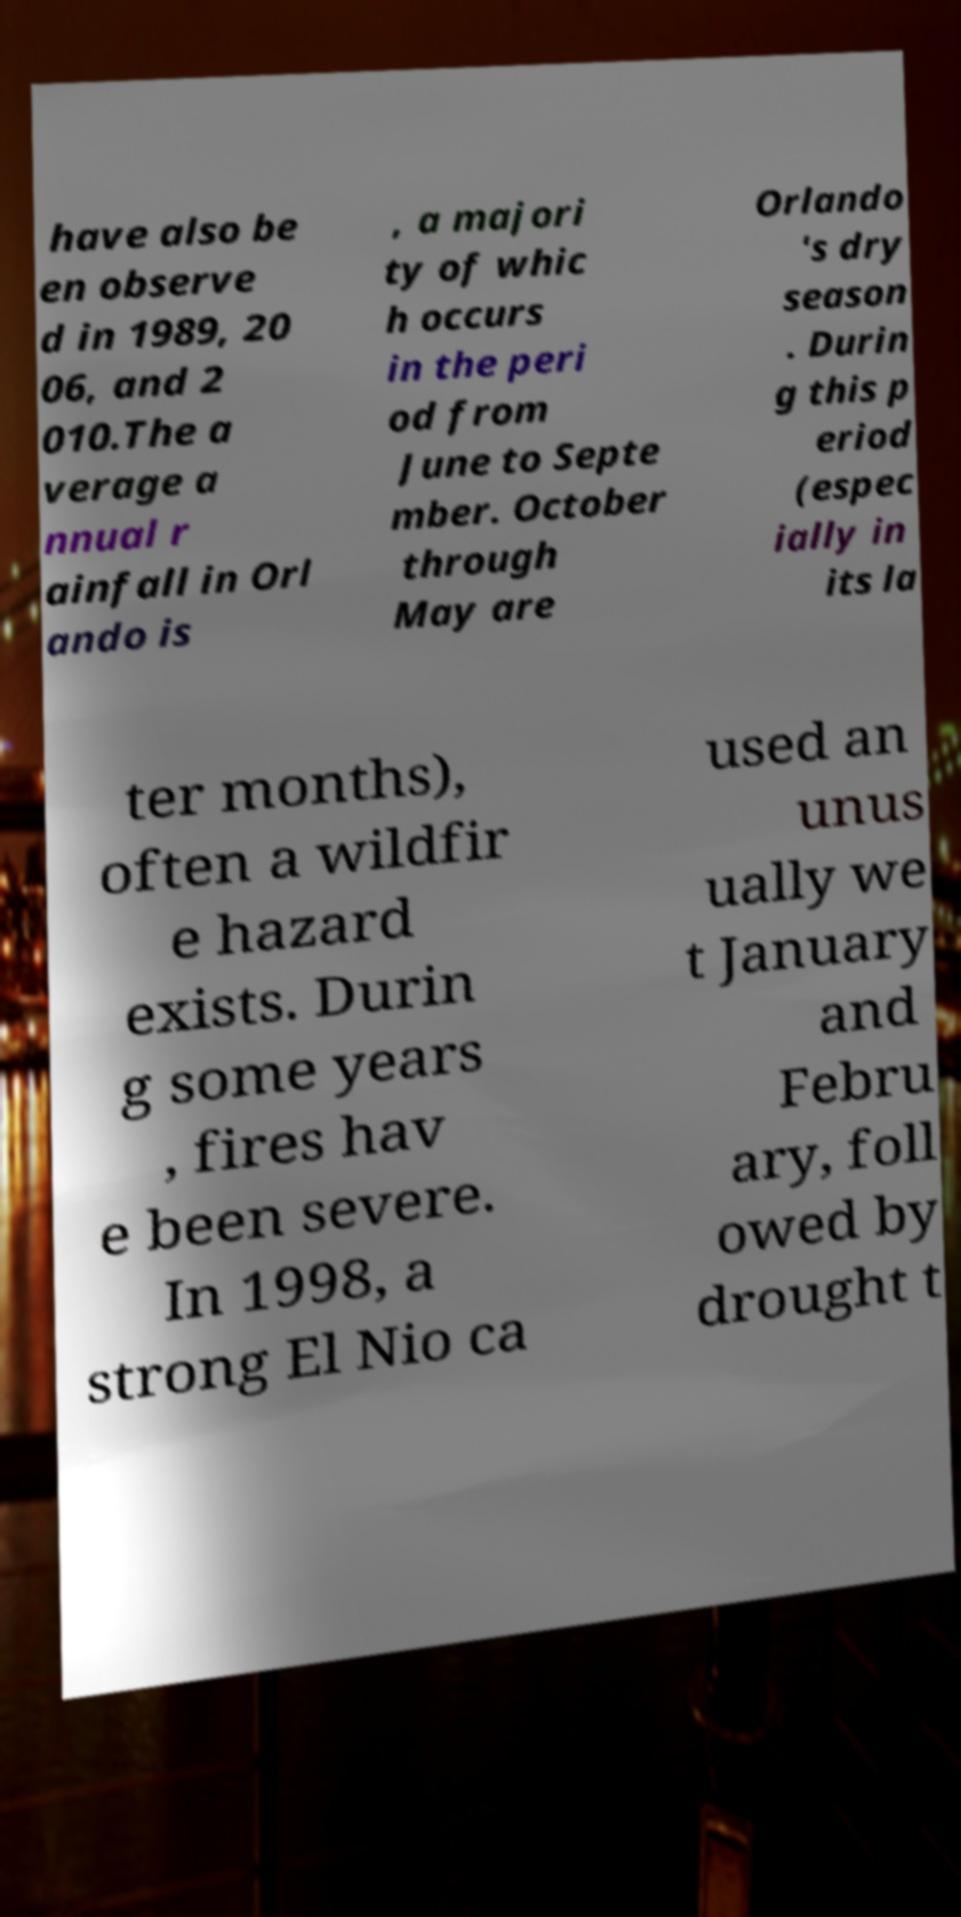Can you accurately transcribe the text from the provided image for me? have also be en observe d in 1989, 20 06, and 2 010.The a verage a nnual r ainfall in Orl ando is , a majori ty of whic h occurs in the peri od from June to Septe mber. October through May are Orlando 's dry season . Durin g this p eriod (espec ially in its la ter months), often a wildfir e hazard exists. Durin g some years , fires hav e been severe. In 1998, a strong El Nio ca used an unus ually we t January and Febru ary, foll owed by drought t 